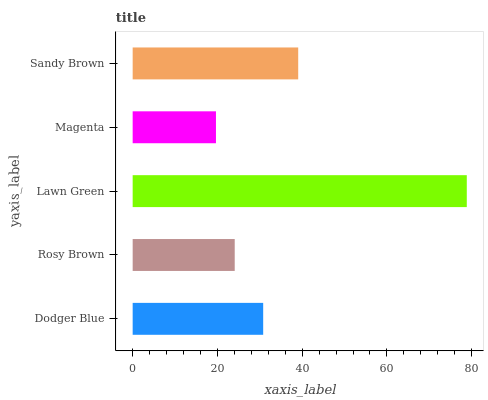Is Magenta the minimum?
Answer yes or no. Yes. Is Lawn Green the maximum?
Answer yes or no. Yes. Is Rosy Brown the minimum?
Answer yes or no. No. Is Rosy Brown the maximum?
Answer yes or no. No. Is Dodger Blue greater than Rosy Brown?
Answer yes or no. Yes. Is Rosy Brown less than Dodger Blue?
Answer yes or no. Yes. Is Rosy Brown greater than Dodger Blue?
Answer yes or no. No. Is Dodger Blue less than Rosy Brown?
Answer yes or no. No. Is Dodger Blue the high median?
Answer yes or no. Yes. Is Dodger Blue the low median?
Answer yes or no. Yes. Is Lawn Green the high median?
Answer yes or no. No. Is Magenta the low median?
Answer yes or no. No. 